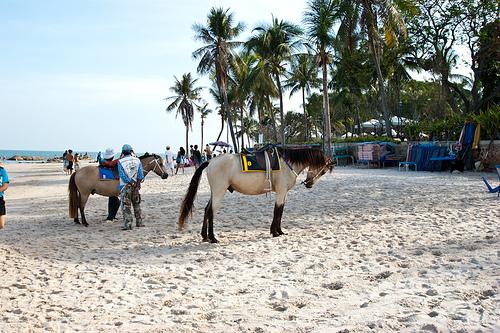Is the horse moving?
Keep it brief. No. Do the animals have short tails?
Give a very brief answer. No. What color is the horse?
Answer briefly. Tan. How many horses are there?
Concise answer only. 2. What kind of trees are on the beach?
Concise answer only. Palm. What is the horse doing?
Be succinct. Standing. Where is the horse looking?
Answer briefly. Down. What animals are visible?
Be succinct. Horses. 